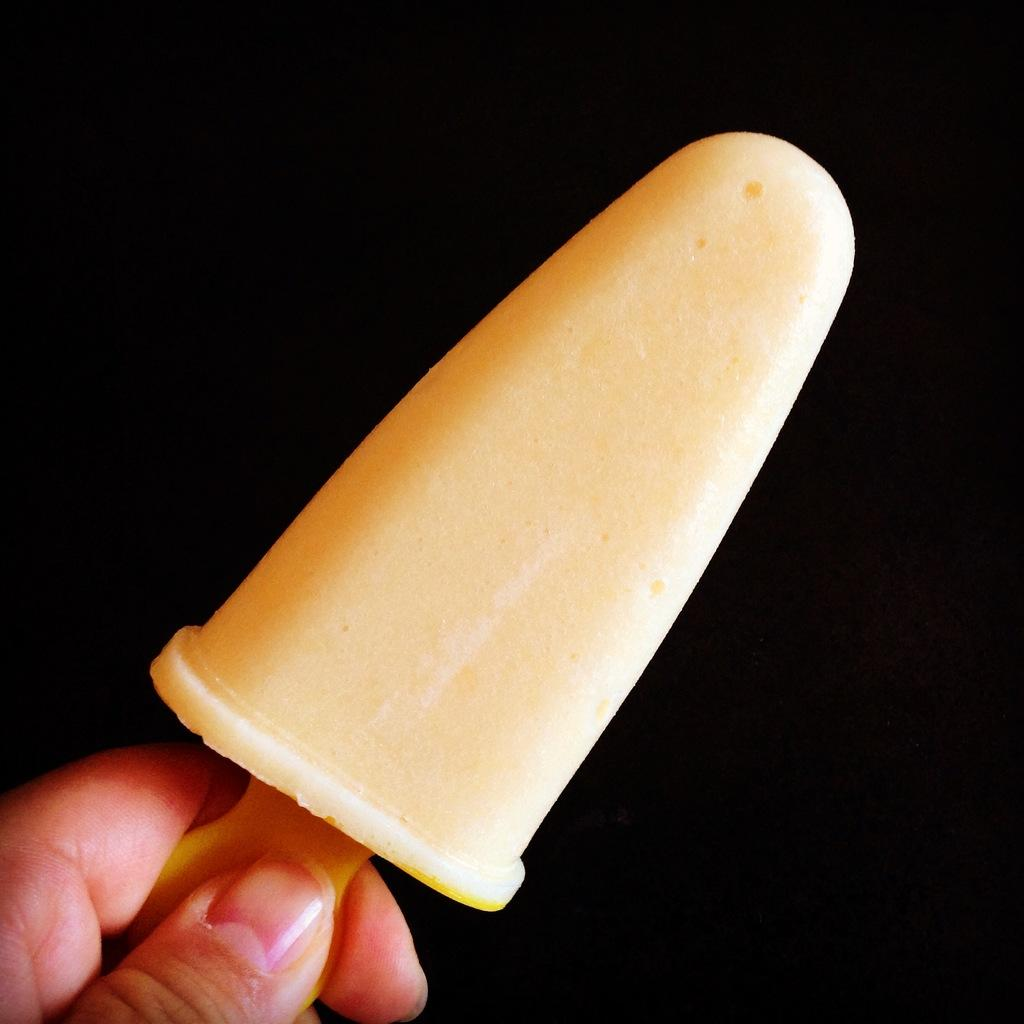What part of a person is visible in the image? There is a person's hand in the image. What is the person holding in the image? The person is holding an ice cream in the image. What type of pain is the person experiencing in the image? There is no indication in the image that the person is experiencing any pain. 